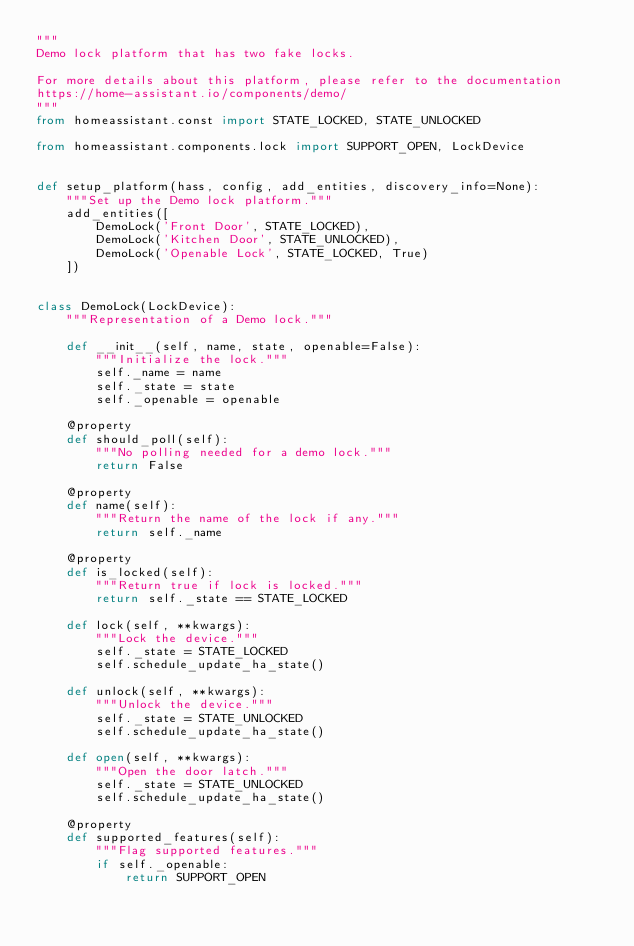<code> <loc_0><loc_0><loc_500><loc_500><_Python_>"""
Demo lock platform that has two fake locks.

For more details about this platform, please refer to the documentation
https://home-assistant.io/components/demo/
"""
from homeassistant.const import STATE_LOCKED, STATE_UNLOCKED

from homeassistant.components.lock import SUPPORT_OPEN, LockDevice


def setup_platform(hass, config, add_entities, discovery_info=None):
    """Set up the Demo lock platform."""
    add_entities([
        DemoLock('Front Door', STATE_LOCKED),
        DemoLock('Kitchen Door', STATE_UNLOCKED),
        DemoLock('Openable Lock', STATE_LOCKED, True)
    ])


class DemoLock(LockDevice):
    """Representation of a Demo lock."""

    def __init__(self, name, state, openable=False):
        """Initialize the lock."""
        self._name = name
        self._state = state
        self._openable = openable

    @property
    def should_poll(self):
        """No polling needed for a demo lock."""
        return False

    @property
    def name(self):
        """Return the name of the lock if any."""
        return self._name

    @property
    def is_locked(self):
        """Return true if lock is locked."""
        return self._state == STATE_LOCKED

    def lock(self, **kwargs):
        """Lock the device."""
        self._state = STATE_LOCKED
        self.schedule_update_ha_state()

    def unlock(self, **kwargs):
        """Unlock the device."""
        self._state = STATE_UNLOCKED
        self.schedule_update_ha_state()

    def open(self, **kwargs):
        """Open the door latch."""
        self._state = STATE_UNLOCKED
        self.schedule_update_ha_state()

    @property
    def supported_features(self):
        """Flag supported features."""
        if self._openable:
            return SUPPORT_OPEN
</code> 